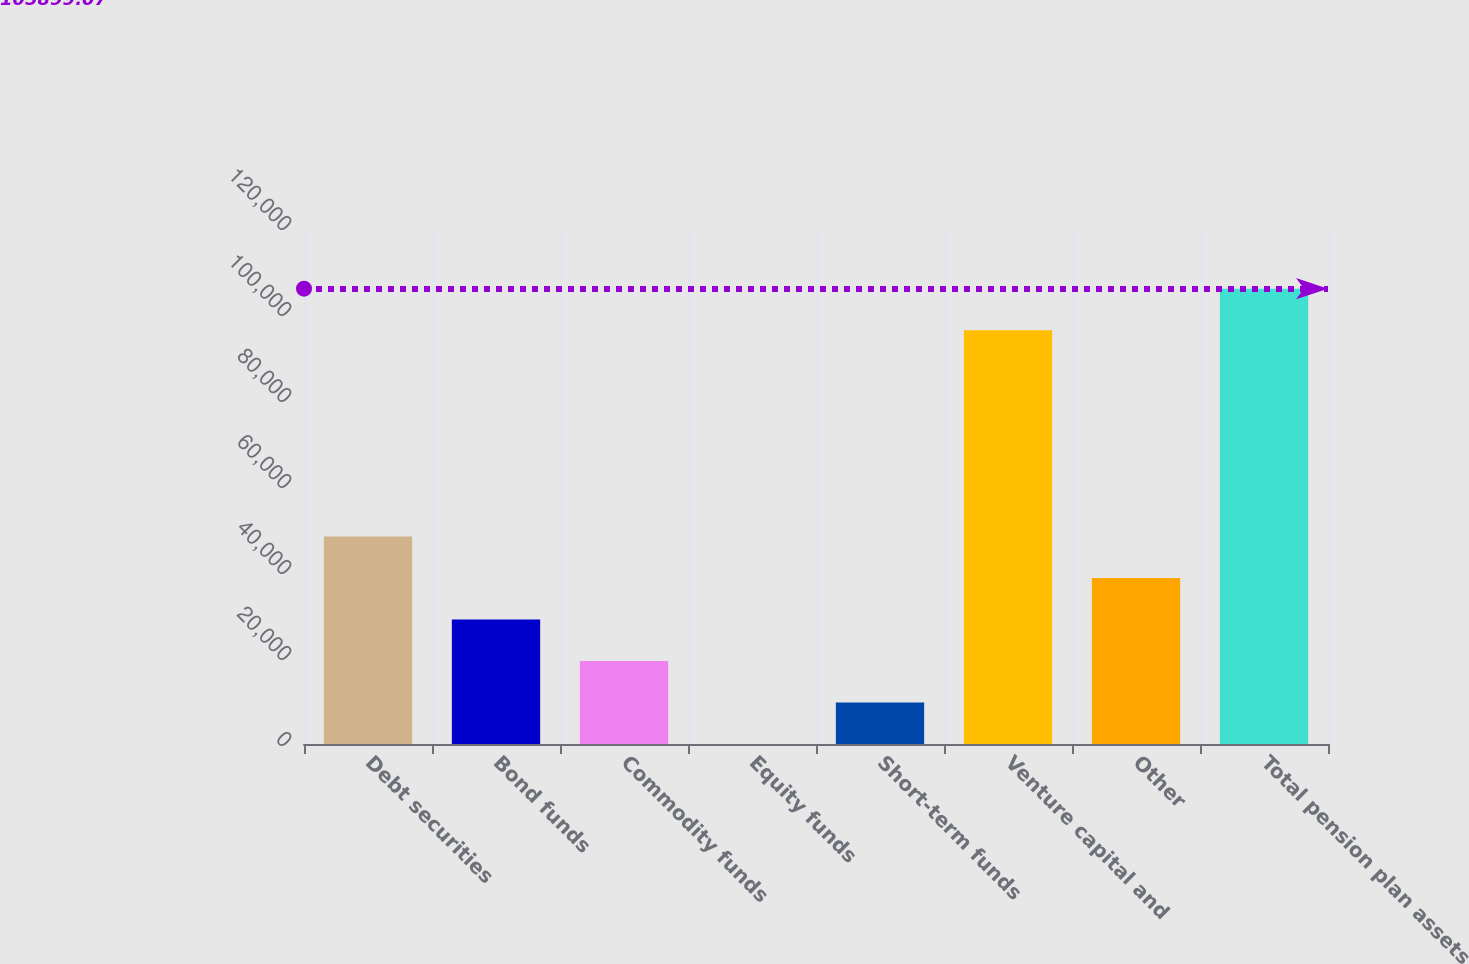Convert chart to OTSL. <chart><loc_0><loc_0><loc_500><loc_500><bar_chart><fcel>Debt securities<fcel>Bond funds<fcel>Commodity funds<fcel>Equity funds<fcel>Short-term funds<fcel>Venture capital and<fcel>Other<fcel>Total pension plan assets<nl><fcel>48276.7<fcel>28966.5<fcel>19311.5<fcel>1.32<fcel>9656.39<fcel>96244<fcel>38621.6<fcel>105899<nl></chart> 